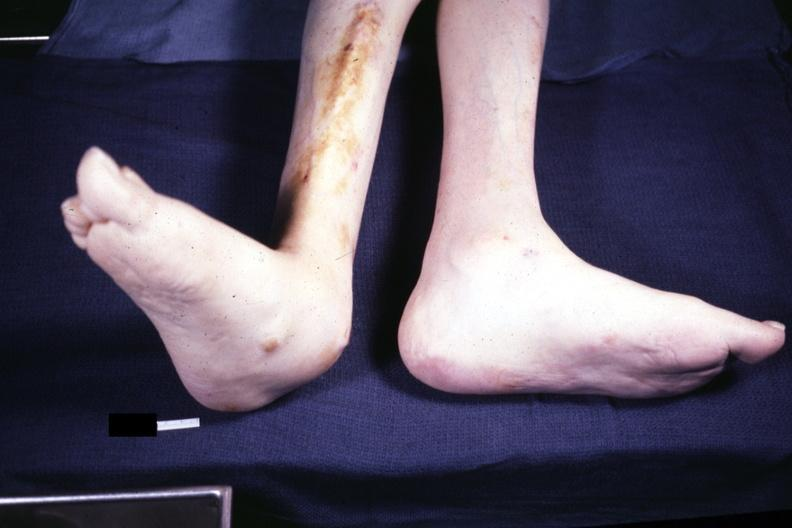how does this image show typical deformity?
Answer the question using a single word or phrase. With lateral deviation case 31 